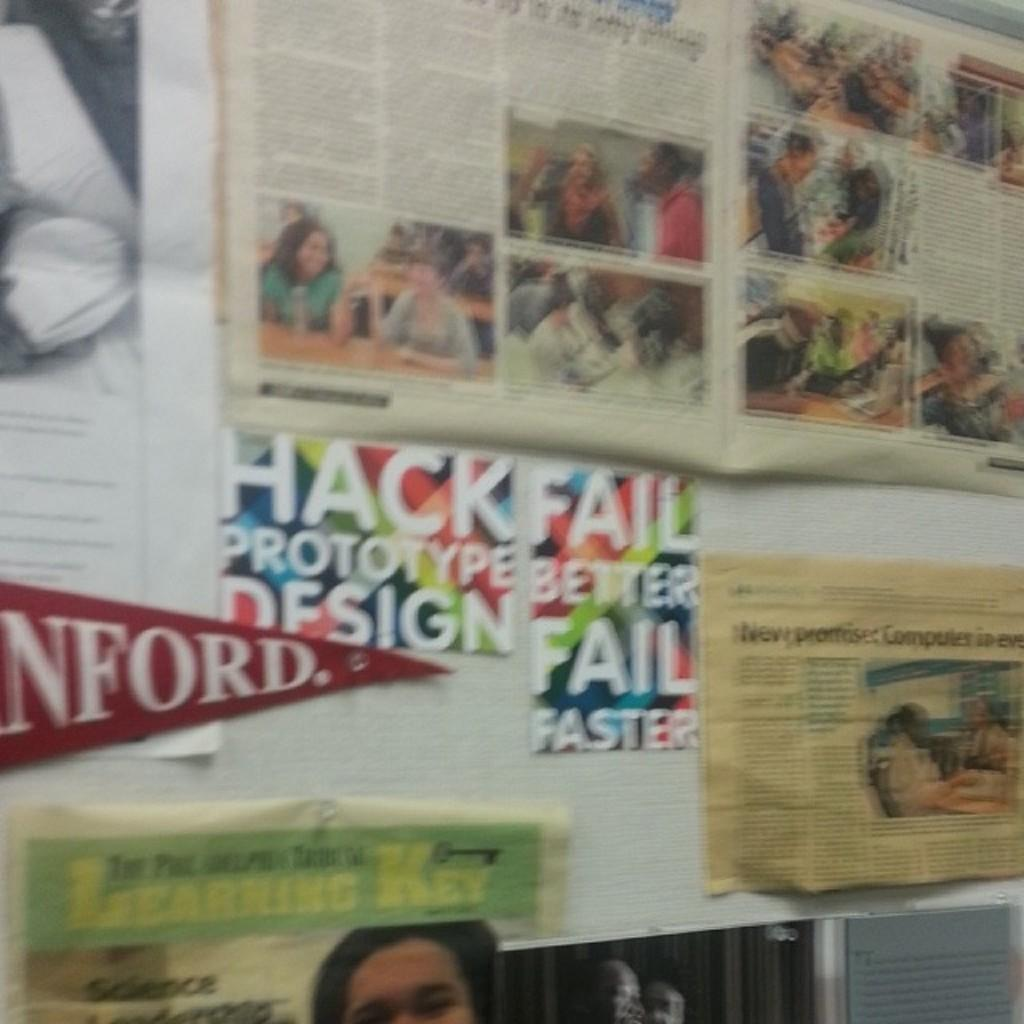<image>
Give a short and clear explanation of the subsequent image. A wall with alot of posters and documents, one about HackFail. 